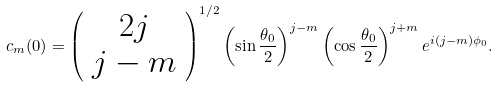<formula> <loc_0><loc_0><loc_500><loc_500>c _ { m } ( 0 ) = { \left ( \begin{array} { c } 2 j \\ j - m \end{array} \right ) } ^ { 1 / 2 } \left ( \sin \frac { \theta _ { 0 } } { 2 } \right ) ^ { j - m } \left ( \cos \frac { \theta _ { 0 } } { 2 } \right ) ^ { j + m } e ^ { i \left ( j - m \right ) \phi _ { 0 } } .</formula> 